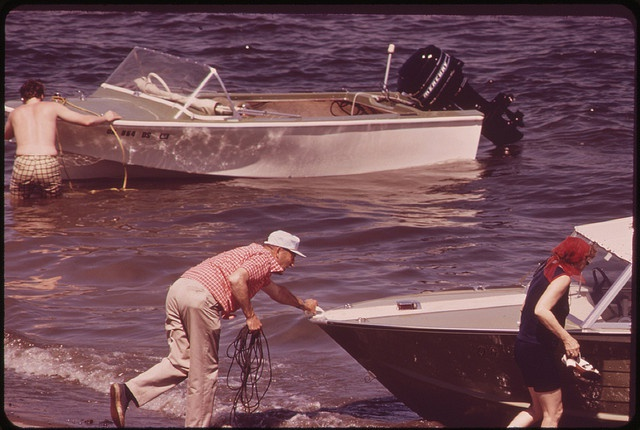Describe the objects in this image and their specific colors. I can see boat in black, brown, pink, and darkgray tones, boat in black, maroon, darkgray, and lightgray tones, people in black, lightpink, brown, maroon, and salmon tones, people in black, maroon, brown, and tan tones, and people in black, lightpink, maroon, and brown tones in this image. 